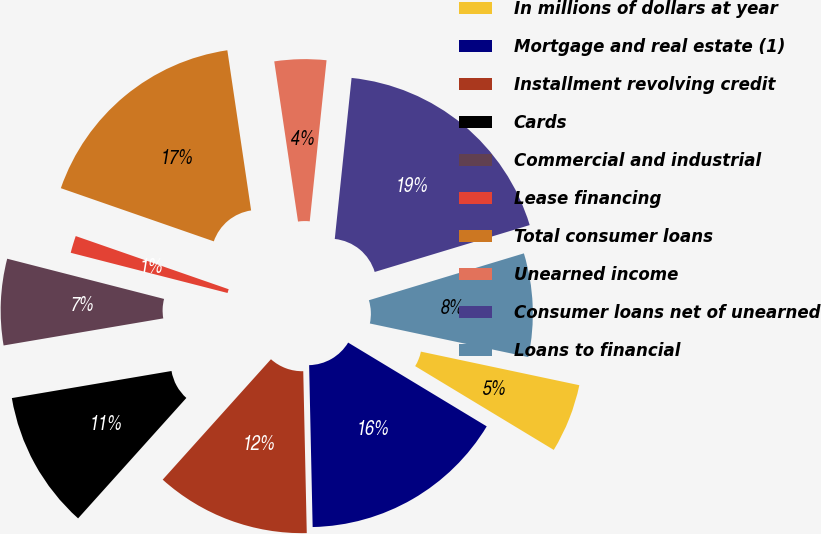Convert chart. <chart><loc_0><loc_0><loc_500><loc_500><pie_chart><fcel>In millions of dollars at year<fcel>Mortgage and real estate (1)<fcel>Installment revolving credit<fcel>Cards<fcel>Commercial and industrial<fcel>Lease financing<fcel>Total consumer loans<fcel>Unearned income<fcel>Consumer loans net of unearned<fcel>Loans to financial<nl><fcel>5.33%<fcel>16.0%<fcel>12.0%<fcel>10.67%<fcel>6.67%<fcel>1.33%<fcel>17.33%<fcel>4.0%<fcel>18.67%<fcel>8.0%<nl></chart> 